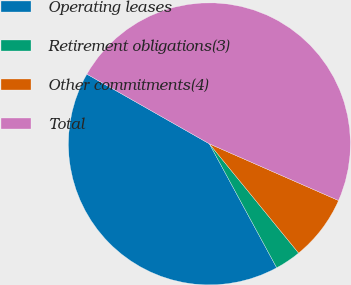Convert chart to OTSL. <chart><loc_0><loc_0><loc_500><loc_500><pie_chart><fcel>Operating leases<fcel>Retirement obligations(3)<fcel>Other commitments(4)<fcel>Total<nl><fcel>41.15%<fcel>2.98%<fcel>7.52%<fcel>48.35%<nl></chart> 